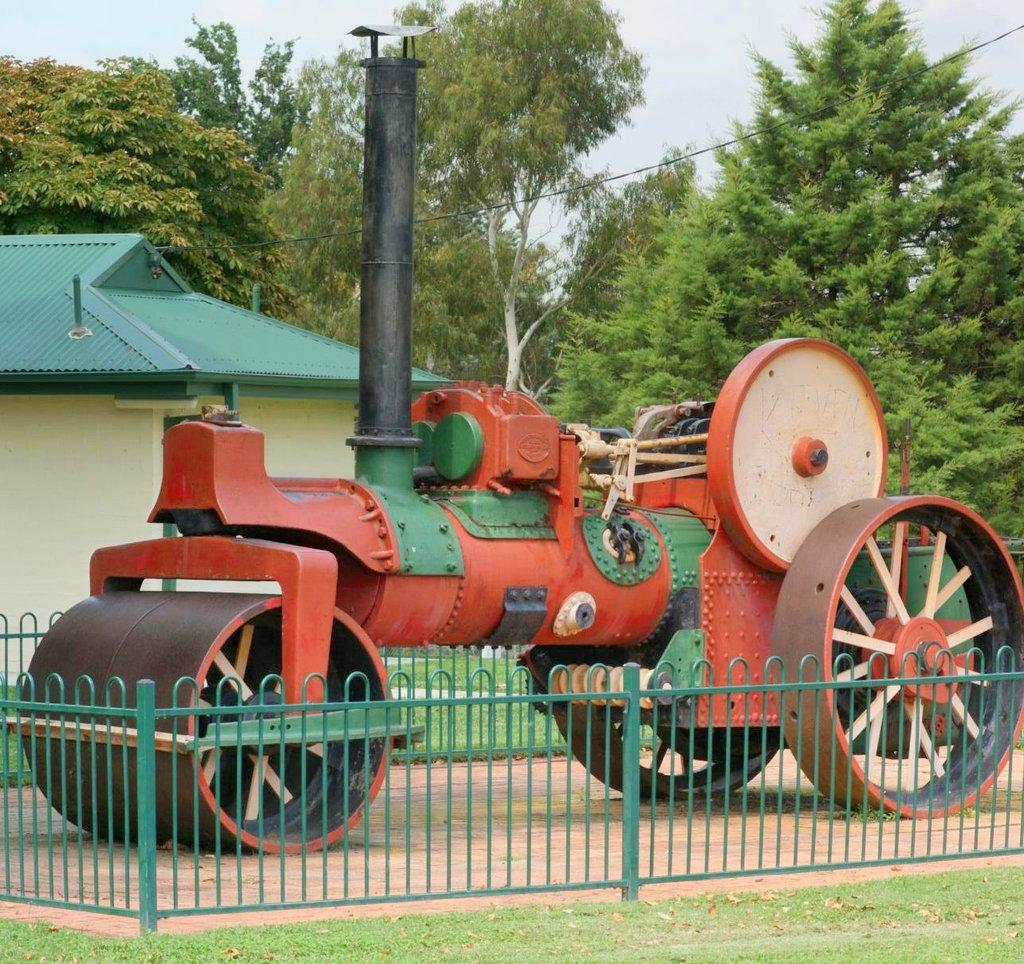What is the main subject in the center of the image? There is a train in the center of the image. What type of barrier surrounds the train? Metal fencing is present around the train. What can be seen in the background of the image? There is a building, trees, and the sky visible in the background of the image. What type of cherries are being served during the recess in the image? There is no recess or cherries present in the image; it features a train surrounded by metal fencing, with a building, trees, and the sky visible in the background. 